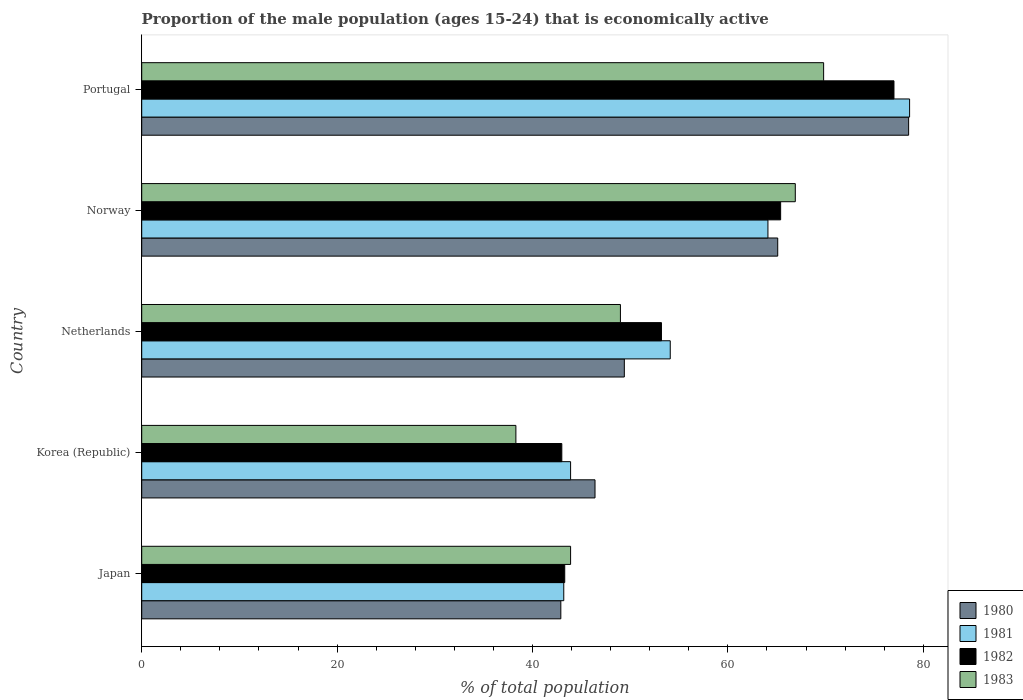How many different coloured bars are there?
Provide a succinct answer. 4. How many groups of bars are there?
Provide a succinct answer. 5. Are the number of bars per tick equal to the number of legend labels?
Your answer should be compact. Yes. Are the number of bars on each tick of the Y-axis equal?
Offer a very short reply. Yes. What is the label of the 4th group of bars from the top?
Offer a terse response. Korea (Republic). What is the proportion of the male population that is economically active in 1983 in Norway?
Give a very brief answer. 66.9. Across all countries, what is the maximum proportion of the male population that is economically active in 1983?
Your response must be concise. 69.8. Across all countries, what is the minimum proportion of the male population that is economically active in 1981?
Your answer should be very brief. 43.2. What is the total proportion of the male population that is economically active in 1983 in the graph?
Make the answer very short. 267.9. What is the difference between the proportion of the male population that is economically active in 1981 in Norway and that in Portugal?
Your response must be concise. -14.5. What is the difference between the proportion of the male population that is economically active in 1983 in Japan and the proportion of the male population that is economically active in 1982 in Netherlands?
Your response must be concise. -9.3. What is the average proportion of the male population that is economically active in 1981 per country?
Provide a short and direct response. 56.78. What is the difference between the proportion of the male population that is economically active in 1981 and proportion of the male population that is economically active in 1982 in Netherlands?
Provide a short and direct response. 0.9. In how many countries, is the proportion of the male population that is economically active in 1983 greater than 68 %?
Give a very brief answer. 1. What is the ratio of the proportion of the male population that is economically active in 1980 in Korea (Republic) to that in Portugal?
Make the answer very short. 0.59. Is the difference between the proportion of the male population that is economically active in 1981 in Japan and Portugal greater than the difference between the proportion of the male population that is economically active in 1982 in Japan and Portugal?
Give a very brief answer. No. What is the difference between the highest and the second highest proportion of the male population that is economically active in 1982?
Give a very brief answer. 11.6. What is the difference between the highest and the lowest proportion of the male population that is economically active in 1983?
Offer a terse response. 31.5. Is it the case that in every country, the sum of the proportion of the male population that is economically active in 1980 and proportion of the male population that is economically active in 1982 is greater than the sum of proportion of the male population that is economically active in 1983 and proportion of the male population that is economically active in 1981?
Ensure brevity in your answer.  No. What does the 2nd bar from the top in Netherlands represents?
Your answer should be compact. 1982. Is it the case that in every country, the sum of the proportion of the male population that is economically active in 1981 and proportion of the male population that is economically active in 1982 is greater than the proportion of the male population that is economically active in 1980?
Provide a succinct answer. Yes. How many bars are there?
Offer a very short reply. 20. How many countries are there in the graph?
Provide a succinct answer. 5. Are the values on the major ticks of X-axis written in scientific E-notation?
Offer a very short reply. No. Does the graph contain any zero values?
Give a very brief answer. No. Does the graph contain grids?
Ensure brevity in your answer.  No. Where does the legend appear in the graph?
Your answer should be very brief. Bottom right. How many legend labels are there?
Give a very brief answer. 4. How are the legend labels stacked?
Ensure brevity in your answer.  Vertical. What is the title of the graph?
Offer a very short reply. Proportion of the male population (ages 15-24) that is economically active. What is the label or title of the X-axis?
Offer a very short reply. % of total population. What is the label or title of the Y-axis?
Offer a terse response. Country. What is the % of total population of 1980 in Japan?
Offer a terse response. 42.9. What is the % of total population of 1981 in Japan?
Provide a succinct answer. 43.2. What is the % of total population in 1982 in Japan?
Keep it short and to the point. 43.3. What is the % of total population of 1983 in Japan?
Provide a short and direct response. 43.9. What is the % of total population in 1980 in Korea (Republic)?
Ensure brevity in your answer.  46.4. What is the % of total population of 1981 in Korea (Republic)?
Your response must be concise. 43.9. What is the % of total population of 1983 in Korea (Republic)?
Your response must be concise. 38.3. What is the % of total population in 1980 in Netherlands?
Your answer should be very brief. 49.4. What is the % of total population of 1981 in Netherlands?
Your response must be concise. 54.1. What is the % of total population of 1982 in Netherlands?
Your response must be concise. 53.2. What is the % of total population of 1980 in Norway?
Offer a terse response. 65.1. What is the % of total population in 1981 in Norway?
Ensure brevity in your answer.  64.1. What is the % of total population in 1982 in Norway?
Offer a terse response. 65.4. What is the % of total population of 1983 in Norway?
Give a very brief answer. 66.9. What is the % of total population in 1980 in Portugal?
Ensure brevity in your answer.  78.5. What is the % of total population in 1981 in Portugal?
Your answer should be compact. 78.6. What is the % of total population in 1983 in Portugal?
Your response must be concise. 69.8. Across all countries, what is the maximum % of total population of 1980?
Your response must be concise. 78.5. Across all countries, what is the maximum % of total population of 1981?
Your answer should be compact. 78.6. Across all countries, what is the maximum % of total population of 1983?
Provide a short and direct response. 69.8. Across all countries, what is the minimum % of total population of 1980?
Provide a short and direct response. 42.9. Across all countries, what is the minimum % of total population in 1981?
Provide a succinct answer. 43.2. Across all countries, what is the minimum % of total population in 1983?
Make the answer very short. 38.3. What is the total % of total population of 1980 in the graph?
Offer a very short reply. 282.3. What is the total % of total population of 1981 in the graph?
Keep it short and to the point. 283.9. What is the total % of total population in 1982 in the graph?
Ensure brevity in your answer.  281.9. What is the total % of total population in 1983 in the graph?
Provide a succinct answer. 267.9. What is the difference between the % of total population of 1980 in Japan and that in Korea (Republic)?
Give a very brief answer. -3.5. What is the difference between the % of total population of 1983 in Japan and that in Korea (Republic)?
Your answer should be compact. 5.6. What is the difference between the % of total population in 1980 in Japan and that in Netherlands?
Offer a very short reply. -6.5. What is the difference between the % of total population in 1981 in Japan and that in Netherlands?
Offer a very short reply. -10.9. What is the difference between the % of total population of 1983 in Japan and that in Netherlands?
Provide a succinct answer. -5.1. What is the difference between the % of total population in 1980 in Japan and that in Norway?
Offer a terse response. -22.2. What is the difference between the % of total population in 1981 in Japan and that in Norway?
Ensure brevity in your answer.  -20.9. What is the difference between the % of total population in 1982 in Japan and that in Norway?
Ensure brevity in your answer.  -22.1. What is the difference between the % of total population in 1980 in Japan and that in Portugal?
Your response must be concise. -35.6. What is the difference between the % of total population of 1981 in Japan and that in Portugal?
Provide a succinct answer. -35.4. What is the difference between the % of total population of 1982 in Japan and that in Portugal?
Your response must be concise. -33.7. What is the difference between the % of total population of 1983 in Japan and that in Portugal?
Your response must be concise. -25.9. What is the difference between the % of total population of 1982 in Korea (Republic) and that in Netherlands?
Offer a terse response. -10.2. What is the difference between the % of total population in 1980 in Korea (Republic) and that in Norway?
Offer a terse response. -18.7. What is the difference between the % of total population in 1981 in Korea (Republic) and that in Norway?
Give a very brief answer. -20.2. What is the difference between the % of total population in 1982 in Korea (Republic) and that in Norway?
Provide a short and direct response. -22.4. What is the difference between the % of total population in 1983 in Korea (Republic) and that in Norway?
Your answer should be very brief. -28.6. What is the difference between the % of total population of 1980 in Korea (Republic) and that in Portugal?
Make the answer very short. -32.1. What is the difference between the % of total population in 1981 in Korea (Republic) and that in Portugal?
Your answer should be compact. -34.7. What is the difference between the % of total population in 1982 in Korea (Republic) and that in Portugal?
Ensure brevity in your answer.  -34. What is the difference between the % of total population in 1983 in Korea (Republic) and that in Portugal?
Your response must be concise. -31.5. What is the difference between the % of total population of 1980 in Netherlands and that in Norway?
Provide a succinct answer. -15.7. What is the difference between the % of total population in 1983 in Netherlands and that in Norway?
Offer a very short reply. -17.9. What is the difference between the % of total population in 1980 in Netherlands and that in Portugal?
Make the answer very short. -29.1. What is the difference between the % of total population of 1981 in Netherlands and that in Portugal?
Make the answer very short. -24.5. What is the difference between the % of total population in 1982 in Netherlands and that in Portugal?
Offer a terse response. -23.8. What is the difference between the % of total population of 1983 in Netherlands and that in Portugal?
Provide a short and direct response. -20.8. What is the difference between the % of total population in 1980 in Norway and that in Portugal?
Keep it short and to the point. -13.4. What is the difference between the % of total population of 1981 in Norway and that in Portugal?
Give a very brief answer. -14.5. What is the difference between the % of total population of 1983 in Norway and that in Portugal?
Make the answer very short. -2.9. What is the difference between the % of total population in 1980 in Japan and the % of total population in 1982 in Korea (Republic)?
Your answer should be compact. -0.1. What is the difference between the % of total population in 1981 in Japan and the % of total population in 1983 in Korea (Republic)?
Offer a very short reply. 4.9. What is the difference between the % of total population of 1982 in Japan and the % of total population of 1983 in Korea (Republic)?
Keep it short and to the point. 5. What is the difference between the % of total population in 1982 in Japan and the % of total population in 1983 in Netherlands?
Give a very brief answer. -5.7. What is the difference between the % of total population in 1980 in Japan and the % of total population in 1981 in Norway?
Offer a very short reply. -21.2. What is the difference between the % of total population of 1980 in Japan and the % of total population of 1982 in Norway?
Keep it short and to the point. -22.5. What is the difference between the % of total population in 1981 in Japan and the % of total population in 1982 in Norway?
Your answer should be very brief. -22.2. What is the difference between the % of total population of 1981 in Japan and the % of total population of 1983 in Norway?
Your answer should be compact. -23.7. What is the difference between the % of total population of 1982 in Japan and the % of total population of 1983 in Norway?
Provide a short and direct response. -23.6. What is the difference between the % of total population in 1980 in Japan and the % of total population in 1981 in Portugal?
Provide a short and direct response. -35.7. What is the difference between the % of total population of 1980 in Japan and the % of total population of 1982 in Portugal?
Your answer should be very brief. -34.1. What is the difference between the % of total population of 1980 in Japan and the % of total population of 1983 in Portugal?
Keep it short and to the point. -26.9. What is the difference between the % of total population of 1981 in Japan and the % of total population of 1982 in Portugal?
Keep it short and to the point. -33.8. What is the difference between the % of total population of 1981 in Japan and the % of total population of 1983 in Portugal?
Offer a terse response. -26.6. What is the difference between the % of total population of 1982 in Japan and the % of total population of 1983 in Portugal?
Offer a very short reply. -26.5. What is the difference between the % of total population in 1980 in Korea (Republic) and the % of total population in 1981 in Netherlands?
Your answer should be very brief. -7.7. What is the difference between the % of total population of 1980 in Korea (Republic) and the % of total population of 1983 in Netherlands?
Ensure brevity in your answer.  -2.6. What is the difference between the % of total population of 1981 in Korea (Republic) and the % of total population of 1982 in Netherlands?
Ensure brevity in your answer.  -9.3. What is the difference between the % of total population of 1981 in Korea (Republic) and the % of total population of 1983 in Netherlands?
Your answer should be very brief. -5.1. What is the difference between the % of total population in 1982 in Korea (Republic) and the % of total population in 1983 in Netherlands?
Provide a short and direct response. -6. What is the difference between the % of total population in 1980 in Korea (Republic) and the % of total population in 1981 in Norway?
Provide a short and direct response. -17.7. What is the difference between the % of total population in 1980 in Korea (Republic) and the % of total population in 1982 in Norway?
Provide a short and direct response. -19. What is the difference between the % of total population in 1980 in Korea (Republic) and the % of total population in 1983 in Norway?
Give a very brief answer. -20.5. What is the difference between the % of total population in 1981 in Korea (Republic) and the % of total population in 1982 in Norway?
Keep it short and to the point. -21.5. What is the difference between the % of total population of 1981 in Korea (Republic) and the % of total population of 1983 in Norway?
Provide a short and direct response. -23. What is the difference between the % of total population in 1982 in Korea (Republic) and the % of total population in 1983 in Norway?
Provide a succinct answer. -23.9. What is the difference between the % of total population of 1980 in Korea (Republic) and the % of total population of 1981 in Portugal?
Your answer should be very brief. -32.2. What is the difference between the % of total population of 1980 in Korea (Republic) and the % of total population of 1982 in Portugal?
Ensure brevity in your answer.  -30.6. What is the difference between the % of total population in 1980 in Korea (Republic) and the % of total population in 1983 in Portugal?
Your answer should be very brief. -23.4. What is the difference between the % of total population of 1981 in Korea (Republic) and the % of total population of 1982 in Portugal?
Offer a very short reply. -33.1. What is the difference between the % of total population of 1981 in Korea (Republic) and the % of total population of 1983 in Portugal?
Offer a very short reply. -25.9. What is the difference between the % of total population of 1982 in Korea (Republic) and the % of total population of 1983 in Portugal?
Give a very brief answer. -26.8. What is the difference between the % of total population in 1980 in Netherlands and the % of total population in 1981 in Norway?
Offer a very short reply. -14.7. What is the difference between the % of total population in 1980 in Netherlands and the % of total population in 1982 in Norway?
Make the answer very short. -16. What is the difference between the % of total population in 1980 in Netherlands and the % of total population in 1983 in Norway?
Your response must be concise. -17.5. What is the difference between the % of total population in 1981 in Netherlands and the % of total population in 1982 in Norway?
Your answer should be compact. -11.3. What is the difference between the % of total population in 1982 in Netherlands and the % of total population in 1983 in Norway?
Provide a succinct answer. -13.7. What is the difference between the % of total population of 1980 in Netherlands and the % of total population of 1981 in Portugal?
Provide a succinct answer. -29.2. What is the difference between the % of total population of 1980 in Netherlands and the % of total population of 1982 in Portugal?
Your response must be concise. -27.6. What is the difference between the % of total population in 1980 in Netherlands and the % of total population in 1983 in Portugal?
Offer a terse response. -20.4. What is the difference between the % of total population in 1981 in Netherlands and the % of total population in 1982 in Portugal?
Your answer should be compact. -22.9. What is the difference between the % of total population in 1981 in Netherlands and the % of total population in 1983 in Portugal?
Offer a terse response. -15.7. What is the difference between the % of total population in 1982 in Netherlands and the % of total population in 1983 in Portugal?
Make the answer very short. -16.6. What is the difference between the % of total population of 1980 in Norway and the % of total population of 1981 in Portugal?
Keep it short and to the point. -13.5. What is the difference between the % of total population of 1980 in Norway and the % of total population of 1983 in Portugal?
Your answer should be very brief. -4.7. What is the difference between the % of total population of 1981 in Norway and the % of total population of 1983 in Portugal?
Offer a very short reply. -5.7. What is the average % of total population in 1980 per country?
Give a very brief answer. 56.46. What is the average % of total population of 1981 per country?
Provide a short and direct response. 56.78. What is the average % of total population of 1982 per country?
Ensure brevity in your answer.  56.38. What is the average % of total population of 1983 per country?
Ensure brevity in your answer.  53.58. What is the difference between the % of total population in 1980 and % of total population in 1981 in Japan?
Your answer should be very brief. -0.3. What is the difference between the % of total population in 1982 and % of total population in 1983 in Japan?
Offer a very short reply. -0.6. What is the difference between the % of total population in 1980 and % of total population in 1982 in Korea (Republic)?
Your response must be concise. 3.4. What is the difference between the % of total population of 1980 and % of total population of 1983 in Korea (Republic)?
Offer a terse response. 8.1. What is the difference between the % of total population of 1982 and % of total population of 1983 in Korea (Republic)?
Your response must be concise. 4.7. What is the difference between the % of total population of 1980 and % of total population of 1982 in Netherlands?
Provide a succinct answer. -3.8. What is the difference between the % of total population of 1981 and % of total population of 1982 in Netherlands?
Your response must be concise. 0.9. What is the difference between the % of total population in 1981 and % of total population in 1983 in Netherlands?
Provide a short and direct response. 5.1. What is the difference between the % of total population of 1980 and % of total population of 1981 in Norway?
Give a very brief answer. 1. What is the difference between the % of total population of 1980 and % of total population of 1982 in Norway?
Provide a short and direct response. -0.3. What is the difference between the % of total population in 1980 and % of total population in 1983 in Norway?
Make the answer very short. -1.8. What is the difference between the % of total population in 1980 and % of total population in 1981 in Portugal?
Your answer should be compact. -0.1. What is the difference between the % of total population in 1980 and % of total population in 1982 in Portugal?
Your response must be concise. 1.5. What is the difference between the % of total population of 1980 and % of total population of 1983 in Portugal?
Your answer should be very brief. 8.7. What is the difference between the % of total population of 1981 and % of total population of 1982 in Portugal?
Ensure brevity in your answer.  1.6. What is the difference between the % of total population of 1981 and % of total population of 1983 in Portugal?
Your answer should be compact. 8.8. What is the difference between the % of total population in 1982 and % of total population in 1983 in Portugal?
Your answer should be very brief. 7.2. What is the ratio of the % of total population in 1980 in Japan to that in Korea (Republic)?
Provide a succinct answer. 0.92. What is the ratio of the % of total population of 1981 in Japan to that in Korea (Republic)?
Offer a terse response. 0.98. What is the ratio of the % of total population of 1983 in Japan to that in Korea (Republic)?
Provide a short and direct response. 1.15. What is the ratio of the % of total population in 1980 in Japan to that in Netherlands?
Give a very brief answer. 0.87. What is the ratio of the % of total population in 1981 in Japan to that in Netherlands?
Keep it short and to the point. 0.8. What is the ratio of the % of total population of 1982 in Japan to that in Netherlands?
Your response must be concise. 0.81. What is the ratio of the % of total population of 1983 in Japan to that in Netherlands?
Your answer should be compact. 0.9. What is the ratio of the % of total population of 1980 in Japan to that in Norway?
Offer a very short reply. 0.66. What is the ratio of the % of total population of 1981 in Japan to that in Norway?
Your answer should be compact. 0.67. What is the ratio of the % of total population in 1982 in Japan to that in Norway?
Provide a succinct answer. 0.66. What is the ratio of the % of total population in 1983 in Japan to that in Norway?
Ensure brevity in your answer.  0.66. What is the ratio of the % of total population in 1980 in Japan to that in Portugal?
Your response must be concise. 0.55. What is the ratio of the % of total population in 1981 in Japan to that in Portugal?
Provide a short and direct response. 0.55. What is the ratio of the % of total population in 1982 in Japan to that in Portugal?
Make the answer very short. 0.56. What is the ratio of the % of total population in 1983 in Japan to that in Portugal?
Your response must be concise. 0.63. What is the ratio of the % of total population of 1980 in Korea (Republic) to that in Netherlands?
Your answer should be compact. 0.94. What is the ratio of the % of total population in 1981 in Korea (Republic) to that in Netherlands?
Give a very brief answer. 0.81. What is the ratio of the % of total population of 1982 in Korea (Republic) to that in Netherlands?
Keep it short and to the point. 0.81. What is the ratio of the % of total population in 1983 in Korea (Republic) to that in Netherlands?
Make the answer very short. 0.78. What is the ratio of the % of total population of 1980 in Korea (Republic) to that in Norway?
Provide a succinct answer. 0.71. What is the ratio of the % of total population in 1981 in Korea (Republic) to that in Norway?
Make the answer very short. 0.68. What is the ratio of the % of total population in 1982 in Korea (Republic) to that in Norway?
Make the answer very short. 0.66. What is the ratio of the % of total population of 1983 in Korea (Republic) to that in Norway?
Make the answer very short. 0.57. What is the ratio of the % of total population of 1980 in Korea (Republic) to that in Portugal?
Offer a terse response. 0.59. What is the ratio of the % of total population in 1981 in Korea (Republic) to that in Portugal?
Ensure brevity in your answer.  0.56. What is the ratio of the % of total population in 1982 in Korea (Republic) to that in Portugal?
Provide a short and direct response. 0.56. What is the ratio of the % of total population in 1983 in Korea (Republic) to that in Portugal?
Your response must be concise. 0.55. What is the ratio of the % of total population of 1980 in Netherlands to that in Norway?
Keep it short and to the point. 0.76. What is the ratio of the % of total population in 1981 in Netherlands to that in Norway?
Your answer should be very brief. 0.84. What is the ratio of the % of total population of 1982 in Netherlands to that in Norway?
Offer a terse response. 0.81. What is the ratio of the % of total population in 1983 in Netherlands to that in Norway?
Provide a short and direct response. 0.73. What is the ratio of the % of total population of 1980 in Netherlands to that in Portugal?
Provide a short and direct response. 0.63. What is the ratio of the % of total population in 1981 in Netherlands to that in Portugal?
Your response must be concise. 0.69. What is the ratio of the % of total population in 1982 in Netherlands to that in Portugal?
Your answer should be very brief. 0.69. What is the ratio of the % of total population of 1983 in Netherlands to that in Portugal?
Keep it short and to the point. 0.7. What is the ratio of the % of total population of 1980 in Norway to that in Portugal?
Ensure brevity in your answer.  0.83. What is the ratio of the % of total population of 1981 in Norway to that in Portugal?
Make the answer very short. 0.82. What is the ratio of the % of total population of 1982 in Norway to that in Portugal?
Provide a short and direct response. 0.85. What is the ratio of the % of total population of 1983 in Norway to that in Portugal?
Ensure brevity in your answer.  0.96. What is the difference between the highest and the second highest % of total population of 1980?
Ensure brevity in your answer.  13.4. What is the difference between the highest and the second highest % of total population in 1982?
Give a very brief answer. 11.6. What is the difference between the highest and the second highest % of total population of 1983?
Provide a short and direct response. 2.9. What is the difference between the highest and the lowest % of total population of 1980?
Give a very brief answer. 35.6. What is the difference between the highest and the lowest % of total population of 1981?
Your answer should be compact. 35.4. What is the difference between the highest and the lowest % of total population of 1982?
Your response must be concise. 34. What is the difference between the highest and the lowest % of total population of 1983?
Your answer should be compact. 31.5. 